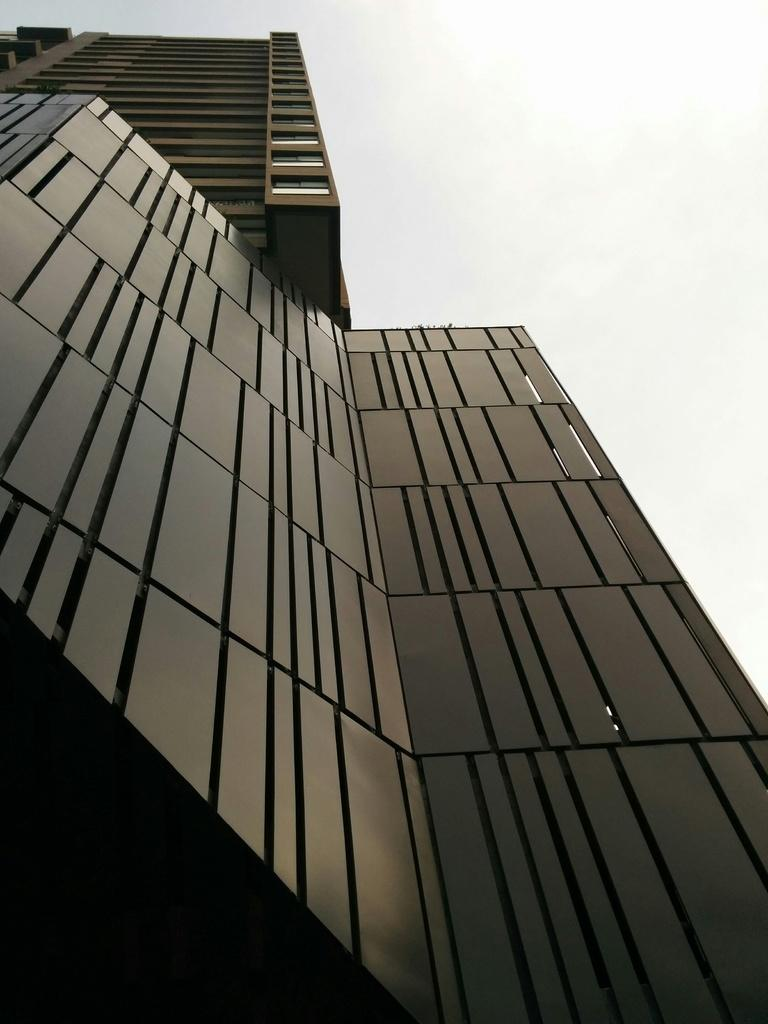What type of structure is present in the image? There is a building in the image. What can be seen in the background of the image? The sky is visible in the background of the image. Can you tell me how many bars of soap are on the roof of the building in the image? There is no information about soap or any objects on the roof of the building in the image. 